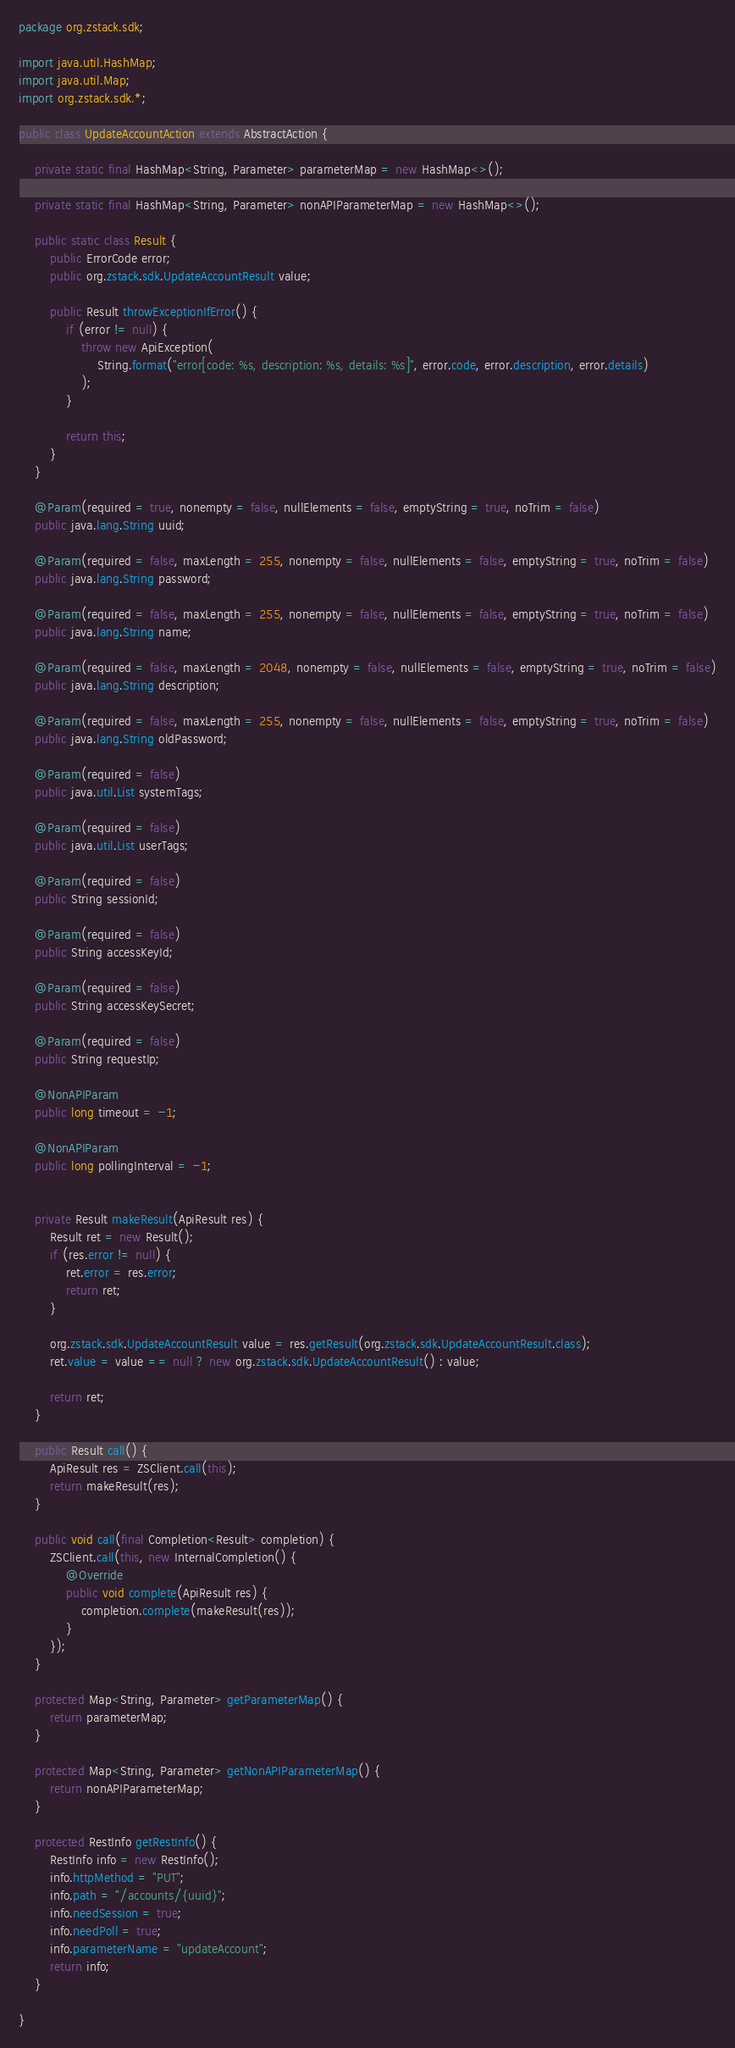Convert code to text. <code><loc_0><loc_0><loc_500><loc_500><_Java_>package org.zstack.sdk;

import java.util.HashMap;
import java.util.Map;
import org.zstack.sdk.*;

public class UpdateAccountAction extends AbstractAction {

    private static final HashMap<String, Parameter> parameterMap = new HashMap<>();

    private static final HashMap<String, Parameter> nonAPIParameterMap = new HashMap<>();

    public static class Result {
        public ErrorCode error;
        public org.zstack.sdk.UpdateAccountResult value;

        public Result throwExceptionIfError() {
            if (error != null) {
                throw new ApiException(
                    String.format("error[code: %s, description: %s, details: %s]", error.code, error.description, error.details)
                );
            }
            
            return this;
        }
    }

    @Param(required = true, nonempty = false, nullElements = false, emptyString = true, noTrim = false)
    public java.lang.String uuid;

    @Param(required = false, maxLength = 255, nonempty = false, nullElements = false, emptyString = true, noTrim = false)
    public java.lang.String password;

    @Param(required = false, maxLength = 255, nonempty = false, nullElements = false, emptyString = true, noTrim = false)
    public java.lang.String name;

    @Param(required = false, maxLength = 2048, nonempty = false, nullElements = false, emptyString = true, noTrim = false)
    public java.lang.String description;

    @Param(required = false, maxLength = 255, nonempty = false, nullElements = false, emptyString = true, noTrim = false)
    public java.lang.String oldPassword;

    @Param(required = false)
    public java.util.List systemTags;

    @Param(required = false)
    public java.util.List userTags;

    @Param(required = false)
    public String sessionId;

    @Param(required = false)
    public String accessKeyId;

    @Param(required = false)
    public String accessKeySecret;

    @Param(required = false)
    public String requestIp;

    @NonAPIParam
    public long timeout = -1;

    @NonAPIParam
    public long pollingInterval = -1;


    private Result makeResult(ApiResult res) {
        Result ret = new Result();
        if (res.error != null) {
            ret.error = res.error;
            return ret;
        }
        
        org.zstack.sdk.UpdateAccountResult value = res.getResult(org.zstack.sdk.UpdateAccountResult.class);
        ret.value = value == null ? new org.zstack.sdk.UpdateAccountResult() : value; 

        return ret;
    }

    public Result call() {
        ApiResult res = ZSClient.call(this);
        return makeResult(res);
    }

    public void call(final Completion<Result> completion) {
        ZSClient.call(this, new InternalCompletion() {
            @Override
            public void complete(ApiResult res) {
                completion.complete(makeResult(res));
            }
        });
    }

    protected Map<String, Parameter> getParameterMap() {
        return parameterMap;
    }

    protected Map<String, Parameter> getNonAPIParameterMap() {
        return nonAPIParameterMap;
    }

    protected RestInfo getRestInfo() {
        RestInfo info = new RestInfo();
        info.httpMethod = "PUT";
        info.path = "/accounts/{uuid}";
        info.needSession = true;
        info.needPoll = true;
        info.parameterName = "updateAccount";
        return info;
    }

}
</code> 